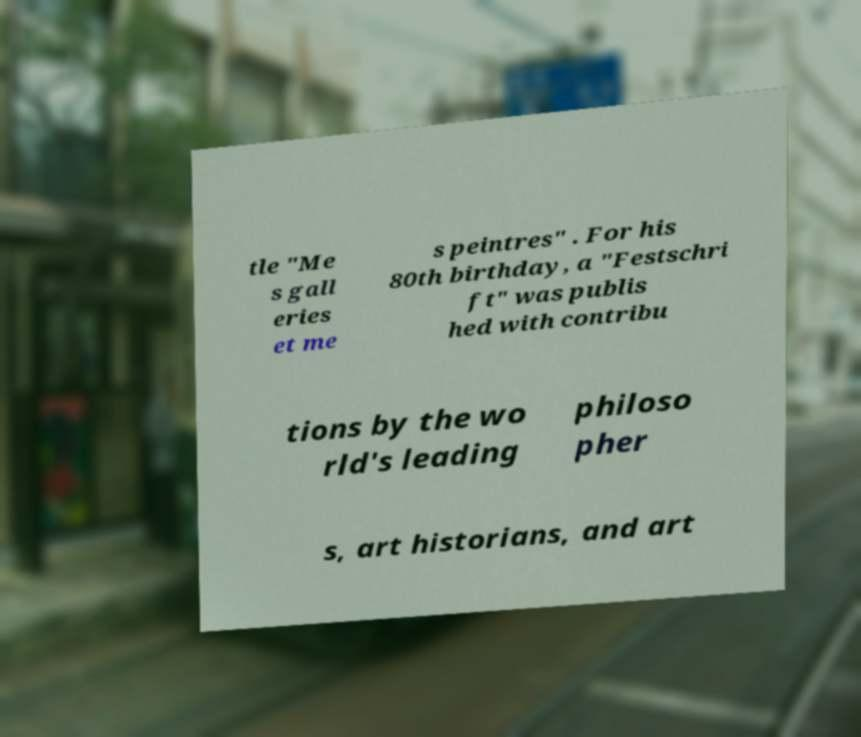There's text embedded in this image that I need extracted. Can you transcribe it verbatim? tle "Me s gall eries et me s peintres" . For his 80th birthday, a "Festschri ft" was publis hed with contribu tions by the wo rld's leading philoso pher s, art historians, and art 